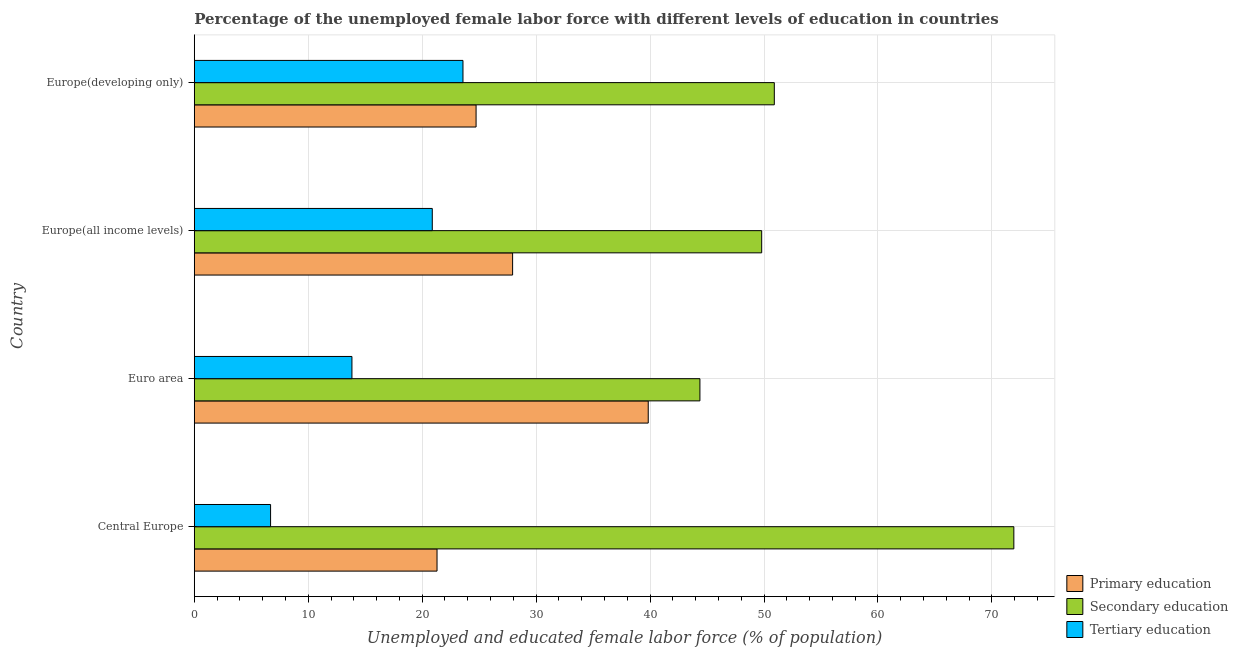How many different coloured bars are there?
Give a very brief answer. 3. Are the number of bars per tick equal to the number of legend labels?
Keep it short and to the point. Yes. How many bars are there on the 3rd tick from the top?
Give a very brief answer. 3. How many bars are there on the 1st tick from the bottom?
Offer a terse response. 3. What is the label of the 1st group of bars from the top?
Keep it short and to the point. Europe(developing only). In how many cases, is the number of bars for a given country not equal to the number of legend labels?
Ensure brevity in your answer.  0. What is the percentage of female labor force who received tertiary education in Euro area?
Make the answer very short. 13.84. Across all countries, what is the maximum percentage of female labor force who received tertiary education?
Offer a terse response. 23.58. Across all countries, what is the minimum percentage of female labor force who received primary education?
Offer a terse response. 21.31. In which country was the percentage of female labor force who received primary education minimum?
Offer a very short reply. Central Europe. What is the total percentage of female labor force who received tertiary education in the graph?
Your response must be concise. 65. What is the difference between the percentage of female labor force who received secondary education in Europe(all income levels) and that in Europe(developing only)?
Offer a terse response. -1.11. What is the difference between the percentage of female labor force who received secondary education in Europe(developing only) and the percentage of female labor force who received tertiary education in Central Europe?
Provide a short and direct response. 44.21. What is the average percentage of female labor force who received tertiary education per country?
Offer a very short reply. 16.25. What is the difference between the percentage of female labor force who received secondary education and percentage of female labor force who received tertiary education in Euro area?
Make the answer very short. 30.54. What is the ratio of the percentage of female labor force who received primary education in Central Europe to that in Europe(developing only)?
Provide a succinct answer. 0.86. Is the percentage of female labor force who received secondary education in Euro area less than that in Europe(all income levels)?
Give a very brief answer. Yes. Is the difference between the percentage of female labor force who received primary education in Euro area and Europe(all income levels) greater than the difference between the percentage of female labor force who received secondary education in Euro area and Europe(all income levels)?
Your answer should be compact. Yes. What is the difference between the highest and the second highest percentage of female labor force who received tertiary education?
Give a very brief answer. 2.69. What is the difference between the highest and the lowest percentage of female labor force who received secondary education?
Your answer should be very brief. 27.55. What does the 1st bar from the top in Europe(all income levels) represents?
Offer a terse response. Tertiary education. What does the 3rd bar from the bottom in Euro area represents?
Offer a very short reply. Tertiary education. Does the graph contain any zero values?
Your answer should be very brief. No. How many legend labels are there?
Provide a succinct answer. 3. How are the legend labels stacked?
Make the answer very short. Vertical. What is the title of the graph?
Offer a terse response. Percentage of the unemployed female labor force with different levels of education in countries. Does "Transport" appear as one of the legend labels in the graph?
Ensure brevity in your answer.  No. What is the label or title of the X-axis?
Ensure brevity in your answer.  Unemployed and educated female labor force (% of population). What is the Unemployed and educated female labor force (% of population) of Primary education in Central Europe?
Offer a very short reply. 21.31. What is the Unemployed and educated female labor force (% of population) of Secondary education in Central Europe?
Your response must be concise. 71.93. What is the Unemployed and educated female labor force (% of population) of Tertiary education in Central Europe?
Keep it short and to the point. 6.7. What is the Unemployed and educated female labor force (% of population) of Primary education in Euro area?
Make the answer very short. 39.84. What is the Unemployed and educated female labor force (% of population) in Secondary education in Euro area?
Give a very brief answer. 44.38. What is the Unemployed and educated female labor force (% of population) of Tertiary education in Euro area?
Ensure brevity in your answer.  13.84. What is the Unemployed and educated female labor force (% of population) of Primary education in Europe(all income levels)?
Give a very brief answer. 27.94. What is the Unemployed and educated female labor force (% of population) of Secondary education in Europe(all income levels)?
Provide a succinct answer. 49.8. What is the Unemployed and educated female labor force (% of population) of Tertiary education in Europe(all income levels)?
Ensure brevity in your answer.  20.89. What is the Unemployed and educated female labor force (% of population) of Primary education in Europe(developing only)?
Your answer should be compact. 24.73. What is the Unemployed and educated female labor force (% of population) in Secondary education in Europe(developing only)?
Your response must be concise. 50.91. What is the Unemployed and educated female labor force (% of population) in Tertiary education in Europe(developing only)?
Give a very brief answer. 23.58. Across all countries, what is the maximum Unemployed and educated female labor force (% of population) in Primary education?
Provide a succinct answer. 39.84. Across all countries, what is the maximum Unemployed and educated female labor force (% of population) of Secondary education?
Your answer should be very brief. 71.93. Across all countries, what is the maximum Unemployed and educated female labor force (% of population) of Tertiary education?
Provide a succinct answer. 23.58. Across all countries, what is the minimum Unemployed and educated female labor force (% of population) of Primary education?
Your response must be concise. 21.31. Across all countries, what is the minimum Unemployed and educated female labor force (% of population) of Secondary education?
Your answer should be compact. 44.38. Across all countries, what is the minimum Unemployed and educated female labor force (% of population) of Tertiary education?
Provide a short and direct response. 6.7. What is the total Unemployed and educated female labor force (% of population) in Primary education in the graph?
Make the answer very short. 113.82. What is the total Unemployed and educated female labor force (% of population) in Secondary education in the graph?
Offer a terse response. 217.01. What is the total Unemployed and educated female labor force (% of population) of Tertiary education in the graph?
Your answer should be compact. 65. What is the difference between the Unemployed and educated female labor force (% of population) in Primary education in Central Europe and that in Euro area?
Provide a short and direct response. -18.54. What is the difference between the Unemployed and educated female labor force (% of population) in Secondary education in Central Europe and that in Euro area?
Offer a very short reply. 27.55. What is the difference between the Unemployed and educated female labor force (% of population) of Tertiary education in Central Europe and that in Euro area?
Provide a short and direct response. -7.14. What is the difference between the Unemployed and educated female labor force (% of population) of Primary education in Central Europe and that in Europe(all income levels)?
Offer a terse response. -6.63. What is the difference between the Unemployed and educated female labor force (% of population) in Secondary education in Central Europe and that in Europe(all income levels)?
Offer a very short reply. 22.13. What is the difference between the Unemployed and educated female labor force (% of population) of Tertiary education in Central Europe and that in Europe(all income levels)?
Provide a short and direct response. -14.19. What is the difference between the Unemployed and educated female labor force (% of population) of Primary education in Central Europe and that in Europe(developing only)?
Give a very brief answer. -3.43. What is the difference between the Unemployed and educated female labor force (% of population) in Secondary education in Central Europe and that in Europe(developing only)?
Your answer should be compact. 21.02. What is the difference between the Unemployed and educated female labor force (% of population) of Tertiary education in Central Europe and that in Europe(developing only)?
Your answer should be compact. -16.88. What is the difference between the Unemployed and educated female labor force (% of population) in Primary education in Euro area and that in Europe(all income levels)?
Keep it short and to the point. 11.9. What is the difference between the Unemployed and educated female labor force (% of population) in Secondary education in Euro area and that in Europe(all income levels)?
Keep it short and to the point. -5.42. What is the difference between the Unemployed and educated female labor force (% of population) of Tertiary education in Euro area and that in Europe(all income levels)?
Make the answer very short. -7.05. What is the difference between the Unemployed and educated female labor force (% of population) of Primary education in Euro area and that in Europe(developing only)?
Offer a very short reply. 15.11. What is the difference between the Unemployed and educated female labor force (% of population) in Secondary education in Euro area and that in Europe(developing only)?
Provide a short and direct response. -6.53. What is the difference between the Unemployed and educated female labor force (% of population) in Tertiary education in Euro area and that in Europe(developing only)?
Your answer should be very brief. -9.74. What is the difference between the Unemployed and educated female labor force (% of population) of Primary education in Europe(all income levels) and that in Europe(developing only)?
Keep it short and to the point. 3.21. What is the difference between the Unemployed and educated female labor force (% of population) in Secondary education in Europe(all income levels) and that in Europe(developing only)?
Make the answer very short. -1.11. What is the difference between the Unemployed and educated female labor force (% of population) of Tertiary education in Europe(all income levels) and that in Europe(developing only)?
Your response must be concise. -2.69. What is the difference between the Unemployed and educated female labor force (% of population) of Primary education in Central Europe and the Unemployed and educated female labor force (% of population) of Secondary education in Euro area?
Provide a succinct answer. -23.07. What is the difference between the Unemployed and educated female labor force (% of population) of Primary education in Central Europe and the Unemployed and educated female labor force (% of population) of Tertiary education in Euro area?
Your answer should be compact. 7.47. What is the difference between the Unemployed and educated female labor force (% of population) in Secondary education in Central Europe and the Unemployed and educated female labor force (% of population) in Tertiary education in Euro area?
Provide a short and direct response. 58.09. What is the difference between the Unemployed and educated female labor force (% of population) in Primary education in Central Europe and the Unemployed and educated female labor force (% of population) in Secondary education in Europe(all income levels)?
Keep it short and to the point. -28.49. What is the difference between the Unemployed and educated female labor force (% of population) in Primary education in Central Europe and the Unemployed and educated female labor force (% of population) in Tertiary education in Europe(all income levels)?
Offer a very short reply. 0.42. What is the difference between the Unemployed and educated female labor force (% of population) of Secondary education in Central Europe and the Unemployed and educated female labor force (% of population) of Tertiary education in Europe(all income levels)?
Provide a short and direct response. 51.04. What is the difference between the Unemployed and educated female labor force (% of population) in Primary education in Central Europe and the Unemployed and educated female labor force (% of population) in Secondary education in Europe(developing only)?
Provide a succinct answer. -29.6. What is the difference between the Unemployed and educated female labor force (% of population) of Primary education in Central Europe and the Unemployed and educated female labor force (% of population) of Tertiary education in Europe(developing only)?
Provide a short and direct response. -2.28. What is the difference between the Unemployed and educated female labor force (% of population) of Secondary education in Central Europe and the Unemployed and educated female labor force (% of population) of Tertiary education in Europe(developing only)?
Offer a very short reply. 48.35. What is the difference between the Unemployed and educated female labor force (% of population) of Primary education in Euro area and the Unemployed and educated female labor force (% of population) of Secondary education in Europe(all income levels)?
Ensure brevity in your answer.  -9.96. What is the difference between the Unemployed and educated female labor force (% of population) in Primary education in Euro area and the Unemployed and educated female labor force (% of population) in Tertiary education in Europe(all income levels)?
Make the answer very short. 18.95. What is the difference between the Unemployed and educated female labor force (% of population) of Secondary education in Euro area and the Unemployed and educated female labor force (% of population) of Tertiary education in Europe(all income levels)?
Provide a short and direct response. 23.49. What is the difference between the Unemployed and educated female labor force (% of population) in Primary education in Euro area and the Unemployed and educated female labor force (% of population) in Secondary education in Europe(developing only)?
Ensure brevity in your answer.  -11.07. What is the difference between the Unemployed and educated female labor force (% of population) in Primary education in Euro area and the Unemployed and educated female labor force (% of population) in Tertiary education in Europe(developing only)?
Offer a terse response. 16.26. What is the difference between the Unemployed and educated female labor force (% of population) in Secondary education in Euro area and the Unemployed and educated female labor force (% of population) in Tertiary education in Europe(developing only)?
Make the answer very short. 20.8. What is the difference between the Unemployed and educated female labor force (% of population) of Primary education in Europe(all income levels) and the Unemployed and educated female labor force (% of population) of Secondary education in Europe(developing only)?
Your response must be concise. -22.97. What is the difference between the Unemployed and educated female labor force (% of population) of Primary education in Europe(all income levels) and the Unemployed and educated female labor force (% of population) of Tertiary education in Europe(developing only)?
Give a very brief answer. 4.36. What is the difference between the Unemployed and educated female labor force (% of population) of Secondary education in Europe(all income levels) and the Unemployed and educated female labor force (% of population) of Tertiary education in Europe(developing only)?
Offer a terse response. 26.22. What is the average Unemployed and educated female labor force (% of population) in Primary education per country?
Your answer should be compact. 28.45. What is the average Unemployed and educated female labor force (% of population) of Secondary education per country?
Your response must be concise. 54.25. What is the average Unemployed and educated female labor force (% of population) of Tertiary education per country?
Your answer should be very brief. 16.25. What is the difference between the Unemployed and educated female labor force (% of population) in Primary education and Unemployed and educated female labor force (% of population) in Secondary education in Central Europe?
Offer a terse response. -50.62. What is the difference between the Unemployed and educated female labor force (% of population) in Primary education and Unemployed and educated female labor force (% of population) in Tertiary education in Central Europe?
Give a very brief answer. 14.61. What is the difference between the Unemployed and educated female labor force (% of population) of Secondary education and Unemployed and educated female labor force (% of population) of Tertiary education in Central Europe?
Your response must be concise. 65.23. What is the difference between the Unemployed and educated female labor force (% of population) of Primary education and Unemployed and educated female labor force (% of population) of Secondary education in Euro area?
Make the answer very short. -4.54. What is the difference between the Unemployed and educated female labor force (% of population) of Primary education and Unemployed and educated female labor force (% of population) of Tertiary education in Euro area?
Ensure brevity in your answer.  26. What is the difference between the Unemployed and educated female labor force (% of population) of Secondary education and Unemployed and educated female labor force (% of population) of Tertiary education in Euro area?
Offer a terse response. 30.54. What is the difference between the Unemployed and educated female labor force (% of population) of Primary education and Unemployed and educated female labor force (% of population) of Secondary education in Europe(all income levels)?
Offer a terse response. -21.86. What is the difference between the Unemployed and educated female labor force (% of population) of Primary education and Unemployed and educated female labor force (% of population) of Tertiary education in Europe(all income levels)?
Provide a short and direct response. 7.05. What is the difference between the Unemployed and educated female labor force (% of population) of Secondary education and Unemployed and educated female labor force (% of population) of Tertiary education in Europe(all income levels)?
Keep it short and to the point. 28.91. What is the difference between the Unemployed and educated female labor force (% of population) in Primary education and Unemployed and educated female labor force (% of population) in Secondary education in Europe(developing only)?
Give a very brief answer. -26.17. What is the difference between the Unemployed and educated female labor force (% of population) in Primary education and Unemployed and educated female labor force (% of population) in Tertiary education in Europe(developing only)?
Keep it short and to the point. 1.15. What is the difference between the Unemployed and educated female labor force (% of population) in Secondary education and Unemployed and educated female labor force (% of population) in Tertiary education in Europe(developing only)?
Give a very brief answer. 27.32. What is the ratio of the Unemployed and educated female labor force (% of population) in Primary education in Central Europe to that in Euro area?
Your response must be concise. 0.53. What is the ratio of the Unemployed and educated female labor force (% of population) in Secondary education in Central Europe to that in Euro area?
Provide a succinct answer. 1.62. What is the ratio of the Unemployed and educated female labor force (% of population) of Tertiary education in Central Europe to that in Euro area?
Give a very brief answer. 0.48. What is the ratio of the Unemployed and educated female labor force (% of population) in Primary education in Central Europe to that in Europe(all income levels)?
Your answer should be very brief. 0.76. What is the ratio of the Unemployed and educated female labor force (% of population) in Secondary education in Central Europe to that in Europe(all income levels)?
Keep it short and to the point. 1.44. What is the ratio of the Unemployed and educated female labor force (% of population) in Tertiary education in Central Europe to that in Europe(all income levels)?
Your answer should be very brief. 0.32. What is the ratio of the Unemployed and educated female labor force (% of population) of Primary education in Central Europe to that in Europe(developing only)?
Ensure brevity in your answer.  0.86. What is the ratio of the Unemployed and educated female labor force (% of population) of Secondary education in Central Europe to that in Europe(developing only)?
Offer a very short reply. 1.41. What is the ratio of the Unemployed and educated female labor force (% of population) in Tertiary education in Central Europe to that in Europe(developing only)?
Ensure brevity in your answer.  0.28. What is the ratio of the Unemployed and educated female labor force (% of population) in Primary education in Euro area to that in Europe(all income levels)?
Provide a short and direct response. 1.43. What is the ratio of the Unemployed and educated female labor force (% of population) of Secondary education in Euro area to that in Europe(all income levels)?
Give a very brief answer. 0.89. What is the ratio of the Unemployed and educated female labor force (% of population) in Tertiary education in Euro area to that in Europe(all income levels)?
Your answer should be compact. 0.66. What is the ratio of the Unemployed and educated female labor force (% of population) in Primary education in Euro area to that in Europe(developing only)?
Your response must be concise. 1.61. What is the ratio of the Unemployed and educated female labor force (% of population) in Secondary education in Euro area to that in Europe(developing only)?
Give a very brief answer. 0.87. What is the ratio of the Unemployed and educated female labor force (% of population) of Tertiary education in Euro area to that in Europe(developing only)?
Your response must be concise. 0.59. What is the ratio of the Unemployed and educated female labor force (% of population) of Primary education in Europe(all income levels) to that in Europe(developing only)?
Give a very brief answer. 1.13. What is the ratio of the Unemployed and educated female labor force (% of population) in Secondary education in Europe(all income levels) to that in Europe(developing only)?
Give a very brief answer. 0.98. What is the ratio of the Unemployed and educated female labor force (% of population) in Tertiary education in Europe(all income levels) to that in Europe(developing only)?
Your response must be concise. 0.89. What is the difference between the highest and the second highest Unemployed and educated female labor force (% of population) in Primary education?
Give a very brief answer. 11.9. What is the difference between the highest and the second highest Unemployed and educated female labor force (% of population) of Secondary education?
Offer a terse response. 21.02. What is the difference between the highest and the second highest Unemployed and educated female labor force (% of population) in Tertiary education?
Offer a very short reply. 2.69. What is the difference between the highest and the lowest Unemployed and educated female labor force (% of population) in Primary education?
Provide a short and direct response. 18.54. What is the difference between the highest and the lowest Unemployed and educated female labor force (% of population) of Secondary education?
Keep it short and to the point. 27.55. What is the difference between the highest and the lowest Unemployed and educated female labor force (% of population) in Tertiary education?
Your answer should be very brief. 16.88. 